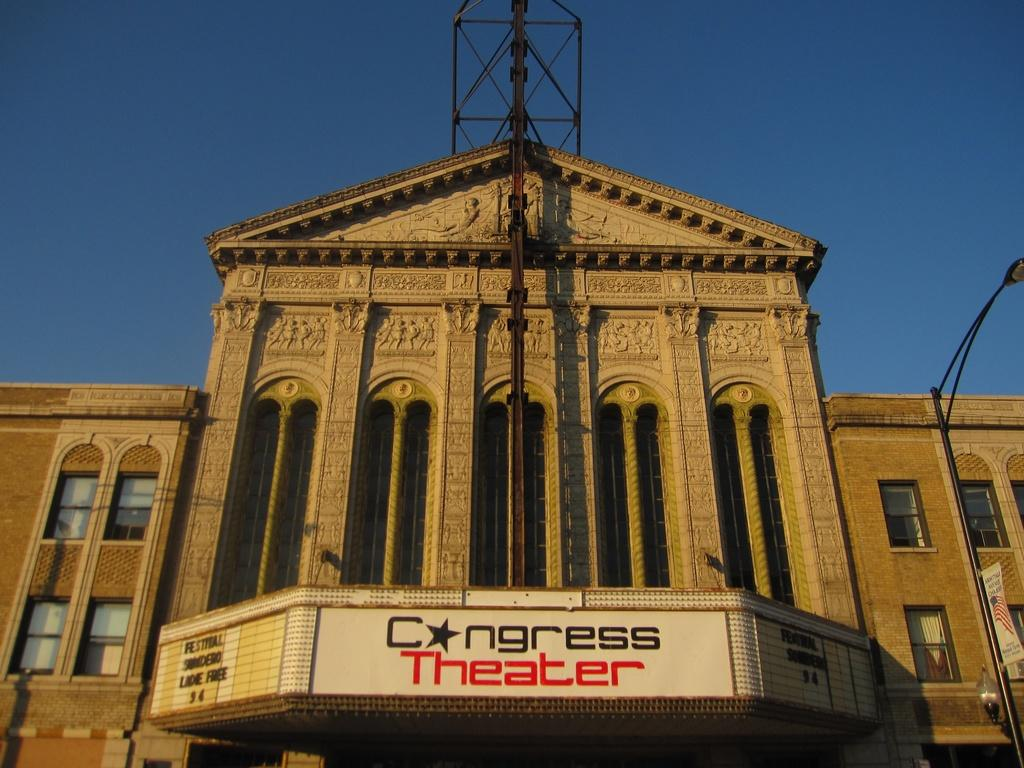What is the main structure in the image? There is a huge building in the image. What colors are used for the building? The building is brown and cream in color. What can be seen besides the building in the image? There is a pole and metal rods in the image. How many windows are visible on the building? There are windows on the building. What is visible in the background of the image? The sky is visible in the background of the image. What type of skin condition is visible on the building in the image? There is no skin condition visible on the building in the image; it is a structure made of materials like brick or concrete. What month is it in the image? The month cannot be determined from the image, as it does not contain any information about the time of year. 